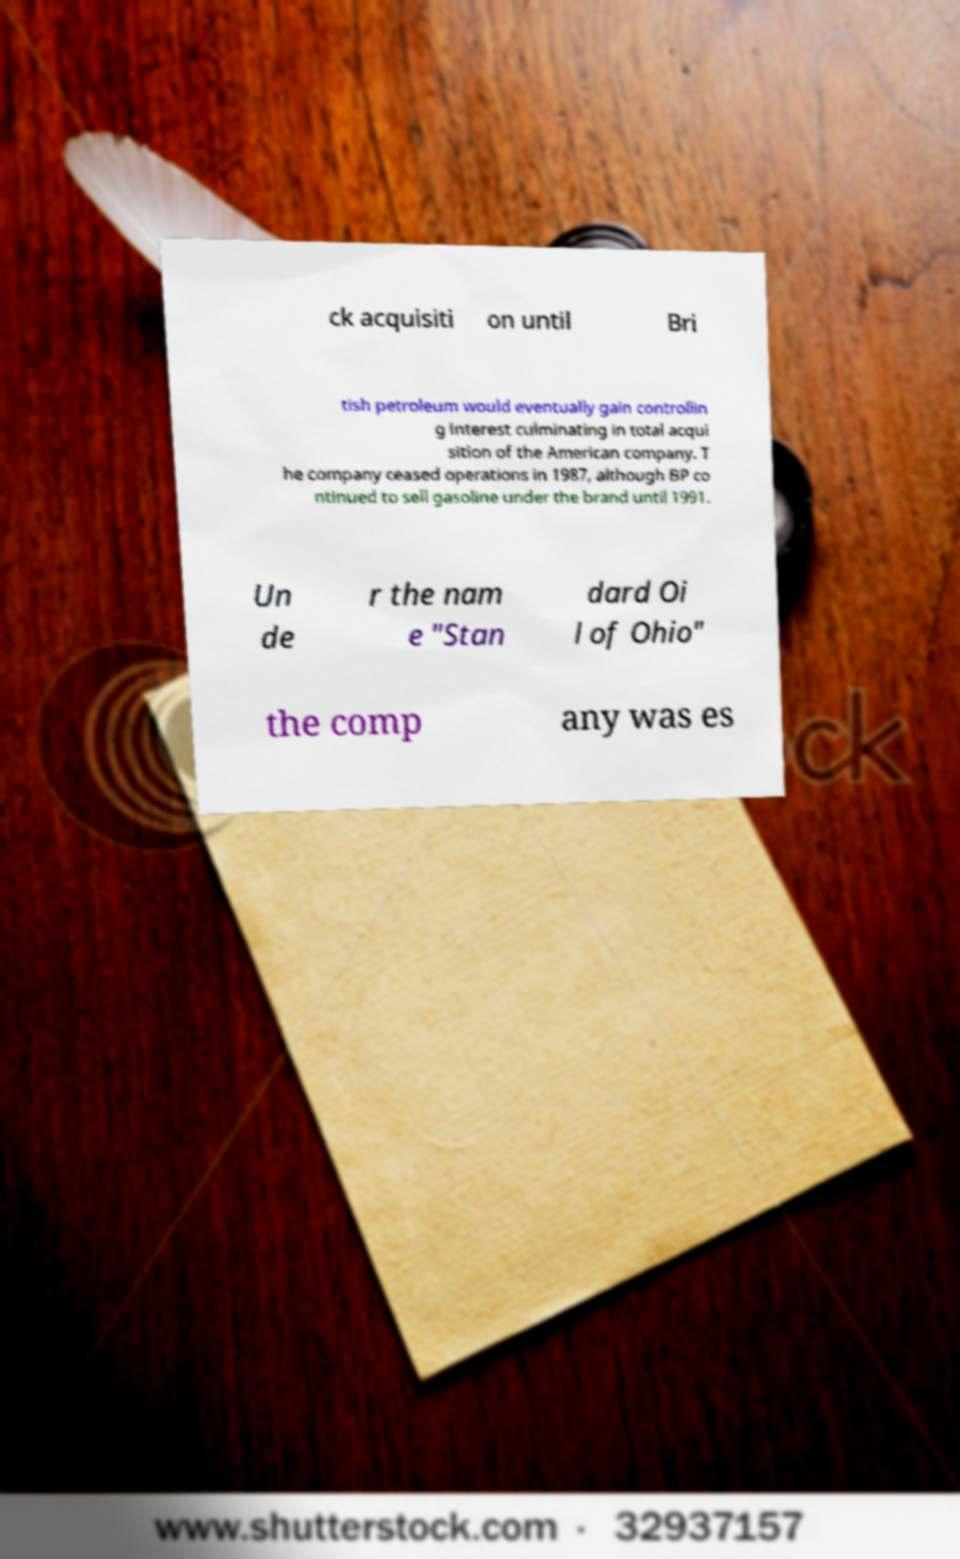Please identify and transcribe the text found in this image. ck acquisiti on until Bri tish petroleum would eventually gain controllin g interest culminating in total acqui sition of the American company. T he company ceased operations in 1987, although BP co ntinued to sell gasoline under the brand until 1991. Un de r the nam e "Stan dard Oi l of Ohio" the comp any was es 